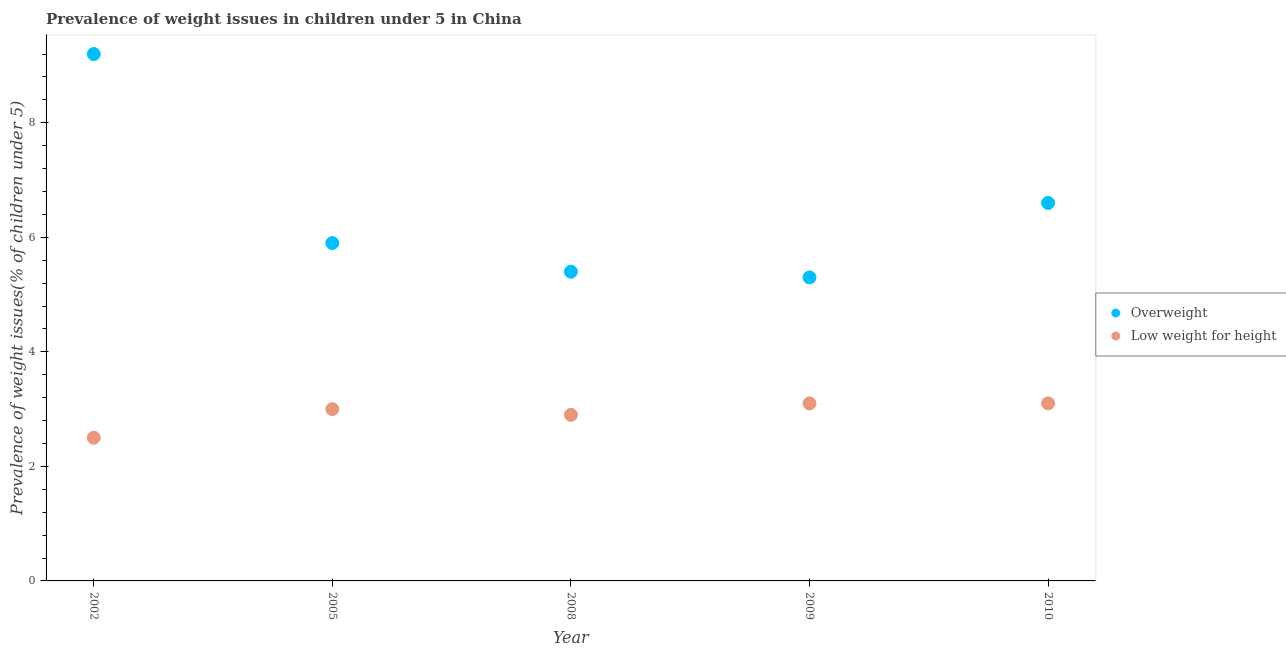Across all years, what is the maximum percentage of underweight children?
Keep it short and to the point. 3.1. Across all years, what is the minimum percentage of overweight children?
Your answer should be compact. 5.3. In which year was the percentage of underweight children maximum?
Provide a short and direct response. 2009. What is the total percentage of underweight children in the graph?
Give a very brief answer. 14.6. What is the difference between the percentage of overweight children in 2002 and that in 2008?
Make the answer very short. 3.8. What is the difference between the percentage of underweight children in 2010 and the percentage of overweight children in 2009?
Provide a short and direct response. -2.2. What is the average percentage of overweight children per year?
Your answer should be very brief. 6.48. In the year 2002, what is the difference between the percentage of overweight children and percentage of underweight children?
Offer a terse response. 6.7. In how many years, is the percentage of overweight children greater than 2.8 %?
Ensure brevity in your answer.  5. What is the ratio of the percentage of overweight children in 2002 to that in 2009?
Your answer should be very brief. 1.74. What is the difference between the highest and the second highest percentage of overweight children?
Offer a terse response. 2.6. What is the difference between the highest and the lowest percentage of overweight children?
Offer a terse response. 3.9. In how many years, is the percentage of underweight children greater than the average percentage of underweight children taken over all years?
Keep it short and to the point. 3. Are the values on the major ticks of Y-axis written in scientific E-notation?
Offer a terse response. No. How are the legend labels stacked?
Make the answer very short. Vertical. What is the title of the graph?
Offer a terse response. Prevalence of weight issues in children under 5 in China. What is the label or title of the Y-axis?
Ensure brevity in your answer.  Prevalence of weight issues(% of children under 5). What is the Prevalence of weight issues(% of children under 5) of Overweight in 2002?
Your answer should be very brief. 9.2. What is the Prevalence of weight issues(% of children under 5) of Overweight in 2005?
Provide a short and direct response. 5.9. What is the Prevalence of weight issues(% of children under 5) of Overweight in 2008?
Your response must be concise. 5.4. What is the Prevalence of weight issues(% of children under 5) of Low weight for height in 2008?
Make the answer very short. 2.9. What is the Prevalence of weight issues(% of children under 5) in Overweight in 2009?
Make the answer very short. 5.3. What is the Prevalence of weight issues(% of children under 5) of Low weight for height in 2009?
Make the answer very short. 3.1. What is the Prevalence of weight issues(% of children under 5) of Overweight in 2010?
Your response must be concise. 6.6. What is the Prevalence of weight issues(% of children under 5) of Low weight for height in 2010?
Offer a terse response. 3.1. Across all years, what is the maximum Prevalence of weight issues(% of children under 5) of Overweight?
Offer a very short reply. 9.2. Across all years, what is the maximum Prevalence of weight issues(% of children under 5) in Low weight for height?
Your response must be concise. 3.1. Across all years, what is the minimum Prevalence of weight issues(% of children under 5) in Overweight?
Ensure brevity in your answer.  5.3. Across all years, what is the minimum Prevalence of weight issues(% of children under 5) of Low weight for height?
Ensure brevity in your answer.  2.5. What is the total Prevalence of weight issues(% of children under 5) of Overweight in the graph?
Your answer should be compact. 32.4. What is the difference between the Prevalence of weight issues(% of children under 5) in Overweight in 2002 and that in 2005?
Give a very brief answer. 3.3. What is the difference between the Prevalence of weight issues(% of children under 5) in Low weight for height in 2002 and that in 2005?
Your answer should be very brief. -0.5. What is the difference between the Prevalence of weight issues(% of children under 5) in Overweight in 2002 and that in 2008?
Offer a very short reply. 3.8. What is the difference between the Prevalence of weight issues(% of children under 5) of Low weight for height in 2002 and that in 2008?
Give a very brief answer. -0.4. What is the difference between the Prevalence of weight issues(% of children under 5) of Low weight for height in 2002 and that in 2009?
Make the answer very short. -0.6. What is the difference between the Prevalence of weight issues(% of children under 5) in Overweight in 2005 and that in 2008?
Make the answer very short. 0.5. What is the difference between the Prevalence of weight issues(% of children under 5) in Low weight for height in 2005 and that in 2008?
Make the answer very short. 0.1. What is the difference between the Prevalence of weight issues(% of children under 5) in Low weight for height in 2005 and that in 2009?
Offer a terse response. -0.1. What is the difference between the Prevalence of weight issues(% of children under 5) in Overweight in 2005 and that in 2010?
Provide a succinct answer. -0.7. What is the difference between the Prevalence of weight issues(% of children under 5) of Low weight for height in 2005 and that in 2010?
Offer a very short reply. -0.1. What is the difference between the Prevalence of weight issues(% of children under 5) of Overweight in 2008 and that in 2009?
Your answer should be compact. 0.1. What is the difference between the Prevalence of weight issues(% of children under 5) of Overweight in 2008 and that in 2010?
Provide a succinct answer. -1.2. What is the difference between the Prevalence of weight issues(% of children under 5) in Overweight in 2009 and that in 2010?
Provide a succinct answer. -1.3. What is the difference between the Prevalence of weight issues(% of children under 5) of Low weight for height in 2009 and that in 2010?
Your answer should be very brief. 0. What is the difference between the Prevalence of weight issues(% of children under 5) of Overweight in 2002 and the Prevalence of weight issues(% of children under 5) of Low weight for height in 2005?
Your answer should be compact. 6.2. What is the difference between the Prevalence of weight issues(% of children under 5) in Overweight in 2002 and the Prevalence of weight issues(% of children under 5) in Low weight for height in 2010?
Provide a short and direct response. 6.1. What is the difference between the Prevalence of weight issues(% of children under 5) in Overweight in 2005 and the Prevalence of weight issues(% of children under 5) in Low weight for height in 2008?
Your answer should be compact. 3. What is the difference between the Prevalence of weight issues(% of children under 5) in Overweight in 2008 and the Prevalence of weight issues(% of children under 5) in Low weight for height in 2009?
Provide a short and direct response. 2.3. What is the difference between the Prevalence of weight issues(% of children under 5) in Overweight in 2008 and the Prevalence of weight issues(% of children under 5) in Low weight for height in 2010?
Offer a terse response. 2.3. What is the difference between the Prevalence of weight issues(% of children under 5) of Overweight in 2009 and the Prevalence of weight issues(% of children under 5) of Low weight for height in 2010?
Your response must be concise. 2.2. What is the average Prevalence of weight issues(% of children under 5) in Overweight per year?
Your answer should be compact. 6.48. What is the average Prevalence of weight issues(% of children under 5) of Low weight for height per year?
Provide a short and direct response. 2.92. In the year 2002, what is the difference between the Prevalence of weight issues(% of children under 5) in Overweight and Prevalence of weight issues(% of children under 5) in Low weight for height?
Your answer should be very brief. 6.7. In the year 2005, what is the difference between the Prevalence of weight issues(% of children under 5) of Overweight and Prevalence of weight issues(% of children under 5) of Low weight for height?
Provide a succinct answer. 2.9. In the year 2008, what is the difference between the Prevalence of weight issues(% of children under 5) in Overweight and Prevalence of weight issues(% of children under 5) in Low weight for height?
Provide a short and direct response. 2.5. What is the ratio of the Prevalence of weight issues(% of children under 5) in Overweight in 2002 to that in 2005?
Keep it short and to the point. 1.56. What is the ratio of the Prevalence of weight issues(% of children under 5) in Overweight in 2002 to that in 2008?
Offer a very short reply. 1.7. What is the ratio of the Prevalence of weight issues(% of children under 5) of Low weight for height in 2002 to that in 2008?
Offer a very short reply. 0.86. What is the ratio of the Prevalence of weight issues(% of children under 5) of Overweight in 2002 to that in 2009?
Your answer should be very brief. 1.74. What is the ratio of the Prevalence of weight issues(% of children under 5) of Low weight for height in 2002 to that in 2009?
Keep it short and to the point. 0.81. What is the ratio of the Prevalence of weight issues(% of children under 5) of Overweight in 2002 to that in 2010?
Your response must be concise. 1.39. What is the ratio of the Prevalence of weight issues(% of children under 5) of Low weight for height in 2002 to that in 2010?
Your answer should be very brief. 0.81. What is the ratio of the Prevalence of weight issues(% of children under 5) in Overweight in 2005 to that in 2008?
Offer a very short reply. 1.09. What is the ratio of the Prevalence of weight issues(% of children under 5) of Low weight for height in 2005 to that in 2008?
Make the answer very short. 1.03. What is the ratio of the Prevalence of weight issues(% of children under 5) in Overweight in 2005 to that in 2009?
Offer a terse response. 1.11. What is the ratio of the Prevalence of weight issues(% of children under 5) of Overweight in 2005 to that in 2010?
Your answer should be very brief. 0.89. What is the ratio of the Prevalence of weight issues(% of children under 5) in Low weight for height in 2005 to that in 2010?
Offer a very short reply. 0.97. What is the ratio of the Prevalence of weight issues(% of children under 5) of Overweight in 2008 to that in 2009?
Your response must be concise. 1.02. What is the ratio of the Prevalence of weight issues(% of children under 5) in Low weight for height in 2008 to that in 2009?
Your answer should be compact. 0.94. What is the ratio of the Prevalence of weight issues(% of children under 5) in Overweight in 2008 to that in 2010?
Offer a very short reply. 0.82. What is the ratio of the Prevalence of weight issues(% of children under 5) of Low weight for height in 2008 to that in 2010?
Your answer should be very brief. 0.94. What is the ratio of the Prevalence of weight issues(% of children under 5) in Overweight in 2009 to that in 2010?
Give a very brief answer. 0.8. What is the difference between the highest and the lowest Prevalence of weight issues(% of children under 5) of Overweight?
Provide a succinct answer. 3.9. 